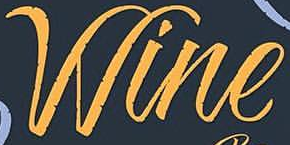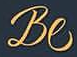What words are shown in these images in order, separated by a semicolon? Wine; Be 